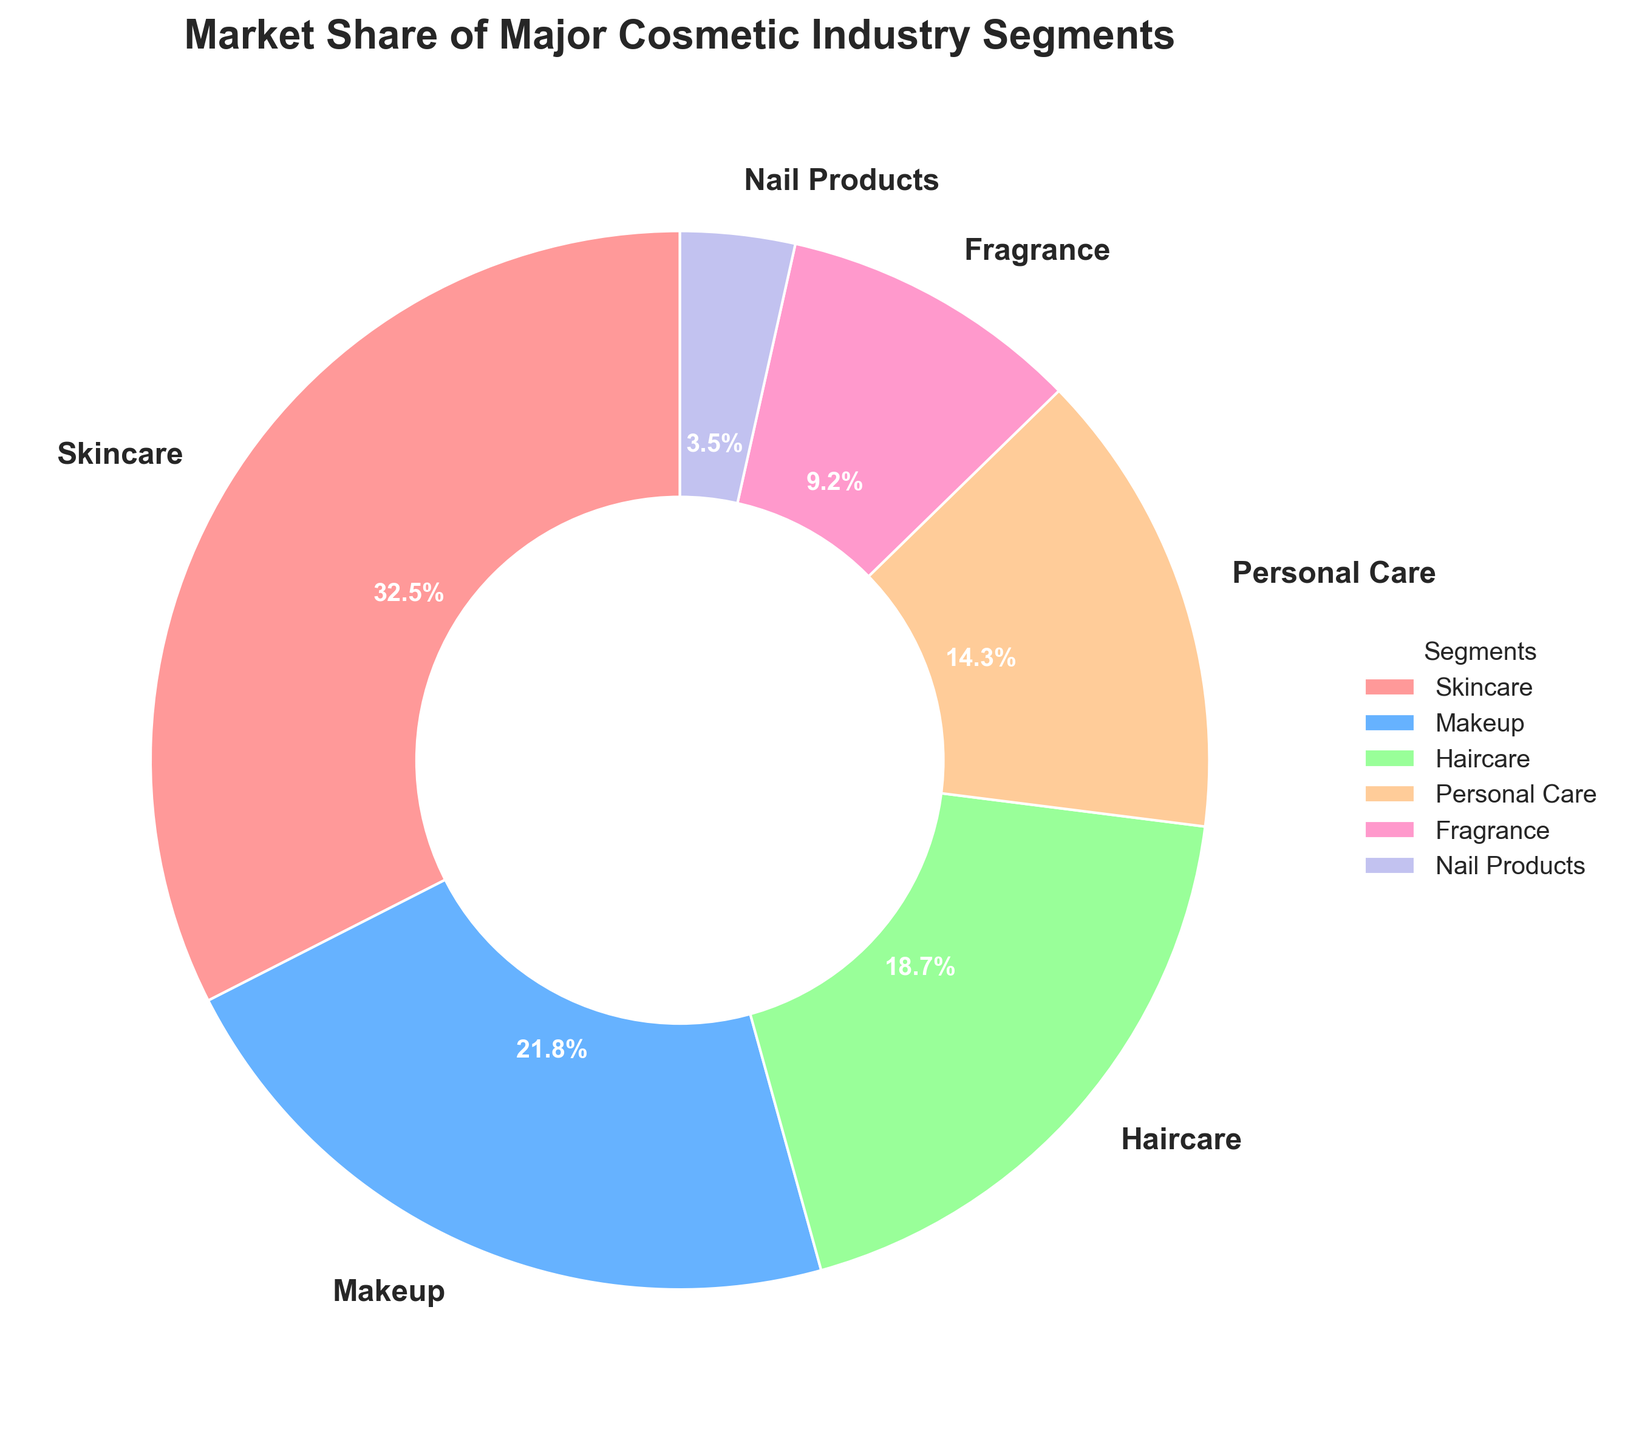What segment has the largest market share? The segment with the largest percentage in the pie chart represents the largest market share. Skincare is labeled with 32.5%, the highest among all.
Answer: Skincare Which two segments together make up just over half of the market? Adding the market shares of the two largest segments, Skincare (32.5%) and Makeup (21.8%), gives a total of 54.3%, which is just over half of the market.
Answer: Skincare and Makeup What is the combined market share of Haircare and Personal Care segments? Adding the market shares of Haircare (18.7%) and Personal Care (14.3%) gives a total of 33%.
Answer: 33% What is the market share difference between the Fragrance and Nail Products segments? Subtract the market share of Nail Products (3.5%) from Fragrance (9.2%) to find the difference. 9.2% - 3.5% = 5.7%.
Answer: 5.7% Which segment has the smallest market share? The segment with the smallest percentage in the pie chart is labeled with 3.5%, which is Nail Products.
Answer: Nail Products Are there more segments with a market share greater than or equal to 20% or less than 20%? Skincare (32.5%) and Makeup (21.8%) are greater than or equal to 20%, totaling 2 segments. Haircare (18.7%), Personal Care (14.3%), Fragrance (9.2%), and Nail Products (3.5%) are less than 20%, totaling 4 segments. Thus, there are more segments with a market share less than 20%.
Answer: Less than 20% What is the most prevalent segment color in the pie chart? Observing the pie chart, the largest segment (Skincare) is marked in red, indicating it as the most prevalent color.
Answer: Red If you were to combine the market share of Fragrance and Personal Care, would it surpass Haircare? Adding the market shares of Fragrance (9.2%) and Personal Care (14.3%) gives a total of 23.5%, which is greater than Haircare's 18.7%.
Answer: Yes By how much does the market share of Makeup exceed that of Haircare? Subtract the market share of Haircare (18.7%) from Makeup (21.8%) to find the excess value. 21.8% - 18.7% = 3.1%.
Answer: 3.1% Does the Personal Care segment have a market share closer to Makeup or Haircare? Comparing the market shares: Makeup (21.8%), Haircare (18.7%), and Personal Care (14.3%). The difference between Personal Care to Makeup is 21.8% - 14.3% = 7.5%, and to Haircare is 18.7% - 14.3% = 4.4%. Hence, it is closer to Haircare.
Answer: Haircare 